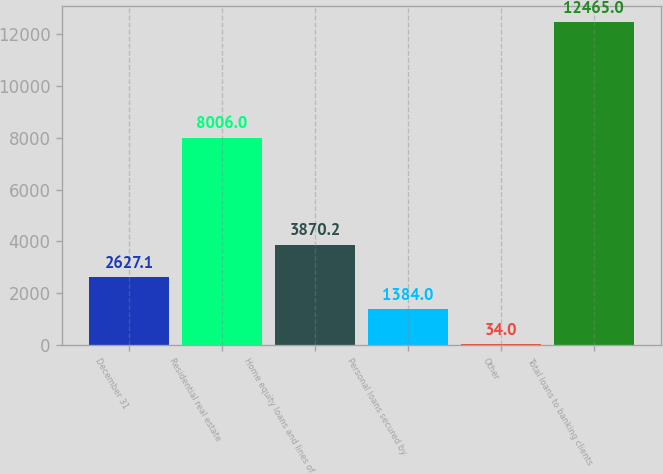Convert chart. <chart><loc_0><loc_0><loc_500><loc_500><bar_chart><fcel>December 31<fcel>Residential real estate<fcel>Home equity loans and lines of<fcel>Personal loans secured by<fcel>Other<fcel>Total loans to banking clients<nl><fcel>2627.1<fcel>8006<fcel>3870.2<fcel>1384<fcel>34<fcel>12465<nl></chart> 